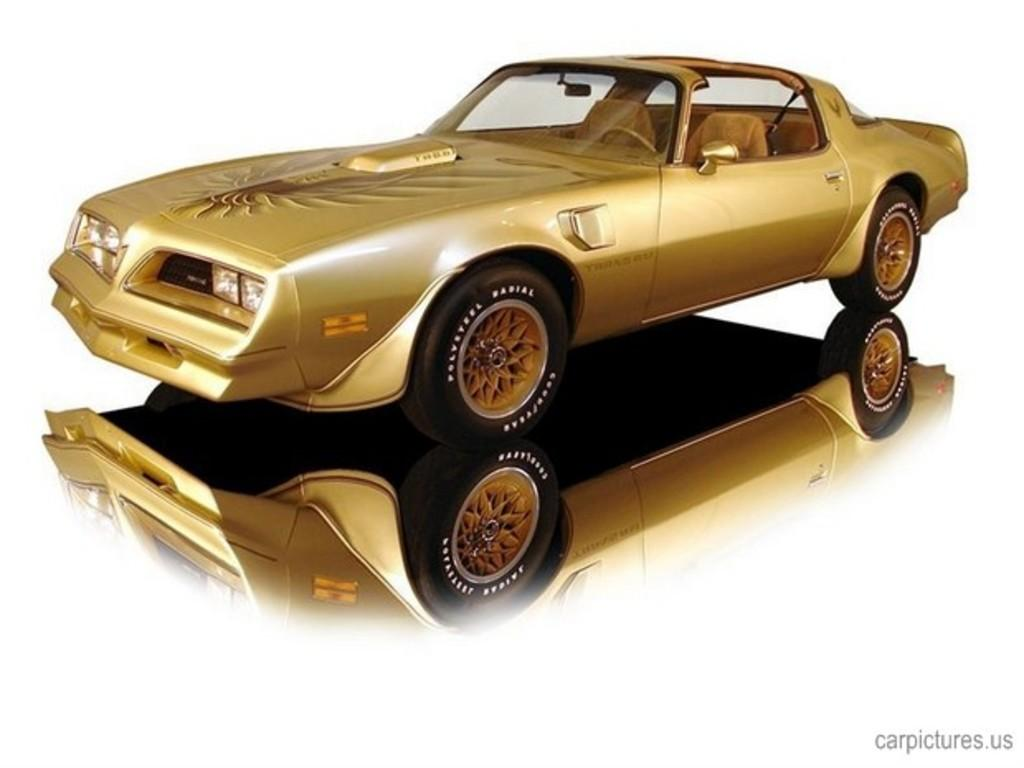What is the main subject of the image? There is a car in the image. Can you describe any other car-related elements in the image? Yes, there is a reflection of a car in the image. What is the color of the background in the image? The background of the image is white. What type of zinc can be seen in the garden in the image? There is no zinc or garden present in the image; it only features a car and its reflection on a white background. 